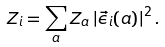Convert formula to latex. <formula><loc_0><loc_0><loc_500><loc_500>Z _ { i } = \sum _ { a } Z _ { a } \left | \vec { \epsilon } _ { i } ( a ) \right | ^ { 2 } .</formula> 